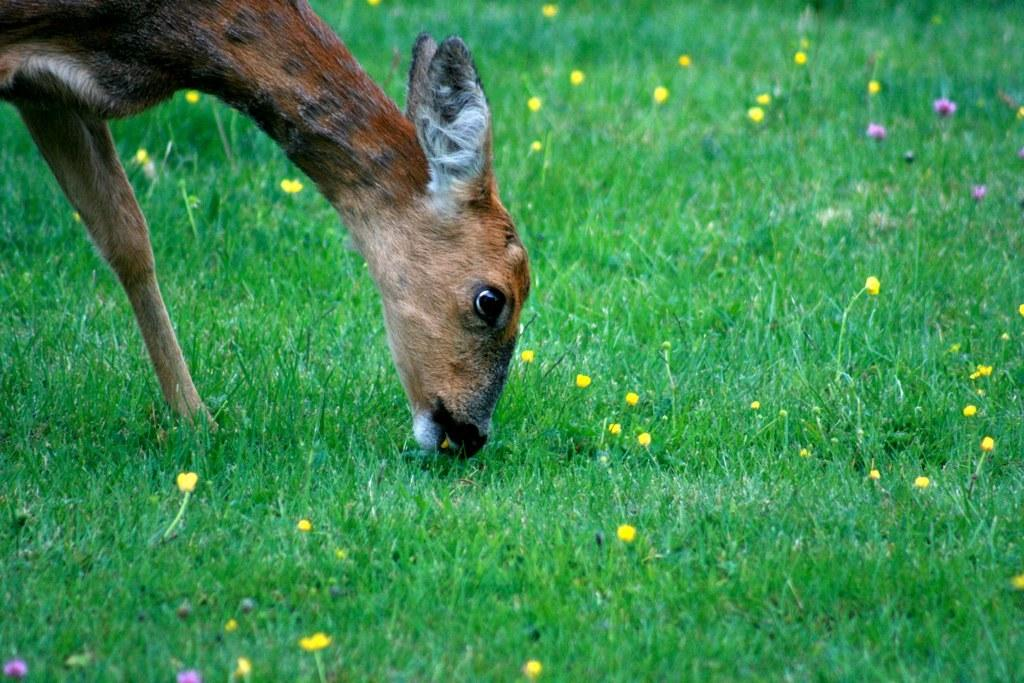What is the animal in the image doing? The animal in the image is eating grass. What type of vegetation is present on the ground in the image? There is grass on the ground in the image. Are there any flowers visible in the image? Yes, there are flowers seen in the image. What type of wish can be granted by the grass in the image? The grass in the image is not associated with granting wishes, as it is a natural element and not a magical or mythical object. --- Transcript: In this picture we can see a person holding a camera and there is a building in the background. Facts: 1. There is a person in the image. 2. The person is holding a camera. 3. There is a building in the background of the image. Conversation: What is the person in the image holding? The person in the image is holding a camera. What can be seen in the background of the image? There is a building in the background of the image. Reasoning: Let's think step by step in order to produce the conversation. We start by identifying the main subject in the image, which is the person holding a camera. Then, we describe the action of the person, mentioning that they are holding a camera. Finally, we acknowledge the presence of the building in the background, which is another detail provided in the facts. Absurd Question/Answer: What type of quicksand can be seen in the image? There is no quicksand present in the image; it features a person holding a camera with a building in the background. --- Transcript: In this image we can see a car parked on the side of the road. There are trees on the side of the road. Facts: 1. There is a car in the image. 2. The car is parked on the side of the road. 3. There are trees on the side of the road. Conversation: What is the main subject of the image? The main subject of the image is a car. What is the car doing in the image? The car is parked on the side of the road. What type of vegetation can be seen on the side of the road? There are trees on the side of the road. Reasoning: Let's think step by step in order to produce the conversation. We start by identifying the main subject in the image, which is the car. Then, we describe the action of the car, mentioning that it is parked on the side of the road. Finally, we acknowledge the presence of trees on the side of the road, which is another detail provided in the facts. Absurd Question/Answer: What type of summer activity is happening in the image? The image does not depict any specific summer activity; it features a parked car and trees on the side of the road 